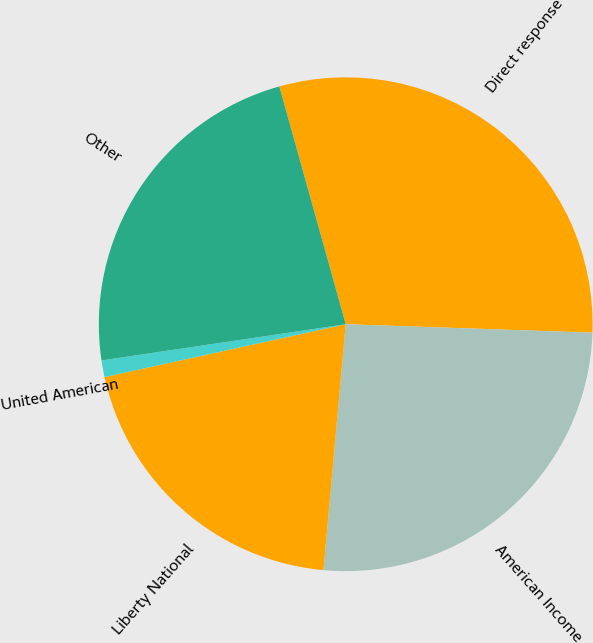<chart> <loc_0><loc_0><loc_500><loc_500><pie_chart><fcel>Direct response<fcel>American Income<fcel>Liberty National<fcel>United American<fcel>Other<nl><fcel>29.88%<fcel>25.89%<fcel>20.13%<fcel>1.09%<fcel>23.01%<nl></chart> 